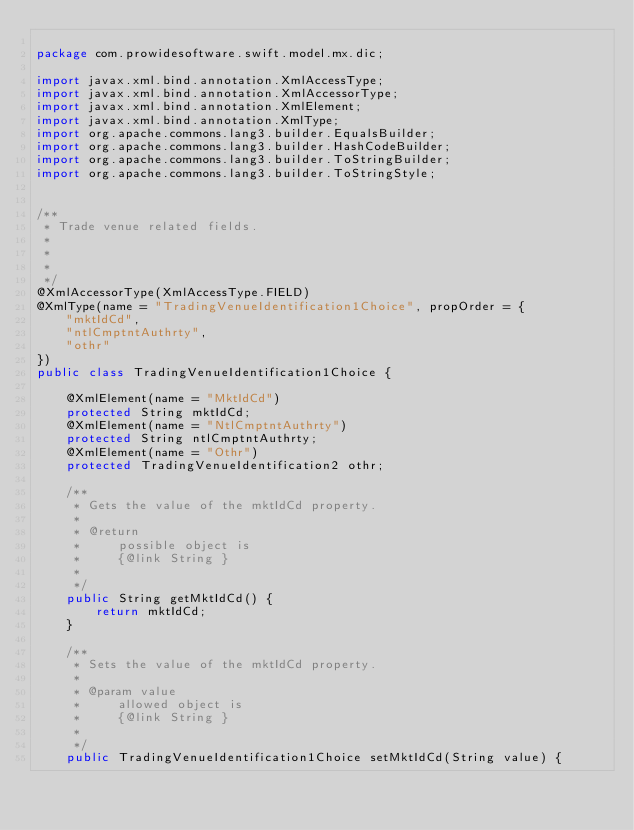Convert code to text. <code><loc_0><loc_0><loc_500><loc_500><_Java_>
package com.prowidesoftware.swift.model.mx.dic;

import javax.xml.bind.annotation.XmlAccessType;
import javax.xml.bind.annotation.XmlAccessorType;
import javax.xml.bind.annotation.XmlElement;
import javax.xml.bind.annotation.XmlType;
import org.apache.commons.lang3.builder.EqualsBuilder;
import org.apache.commons.lang3.builder.HashCodeBuilder;
import org.apache.commons.lang3.builder.ToStringBuilder;
import org.apache.commons.lang3.builder.ToStringStyle;


/**
 * Trade venue related fields.
 * 
 * 
 * 
 */
@XmlAccessorType(XmlAccessType.FIELD)
@XmlType(name = "TradingVenueIdentification1Choice", propOrder = {
    "mktIdCd",
    "ntlCmptntAuthrty",
    "othr"
})
public class TradingVenueIdentification1Choice {

    @XmlElement(name = "MktIdCd")
    protected String mktIdCd;
    @XmlElement(name = "NtlCmptntAuthrty")
    protected String ntlCmptntAuthrty;
    @XmlElement(name = "Othr")
    protected TradingVenueIdentification2 othr;

    /**
     * Gets the value of the mktIdCd property.
     * 
     * @return
     *     possible object is
     *     {@link String }
     *     
     */
    public String getMktIdCd() {
        return mktIdCd;
    }

    /**
     * Sets the value of the mktIdCd property.
     * 
     * @param value
     *     allowed object is
     *     {@link String }
     *     
     */
    public TradingVenueIdentification1Choice setMktIdCd(String value) {</code> 